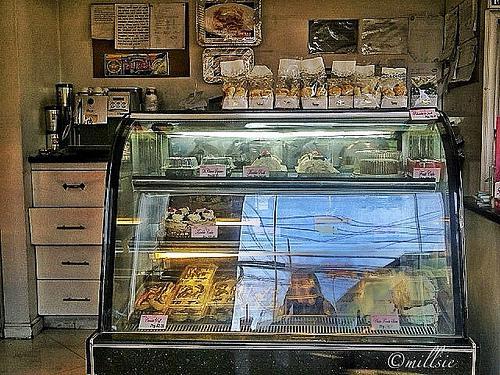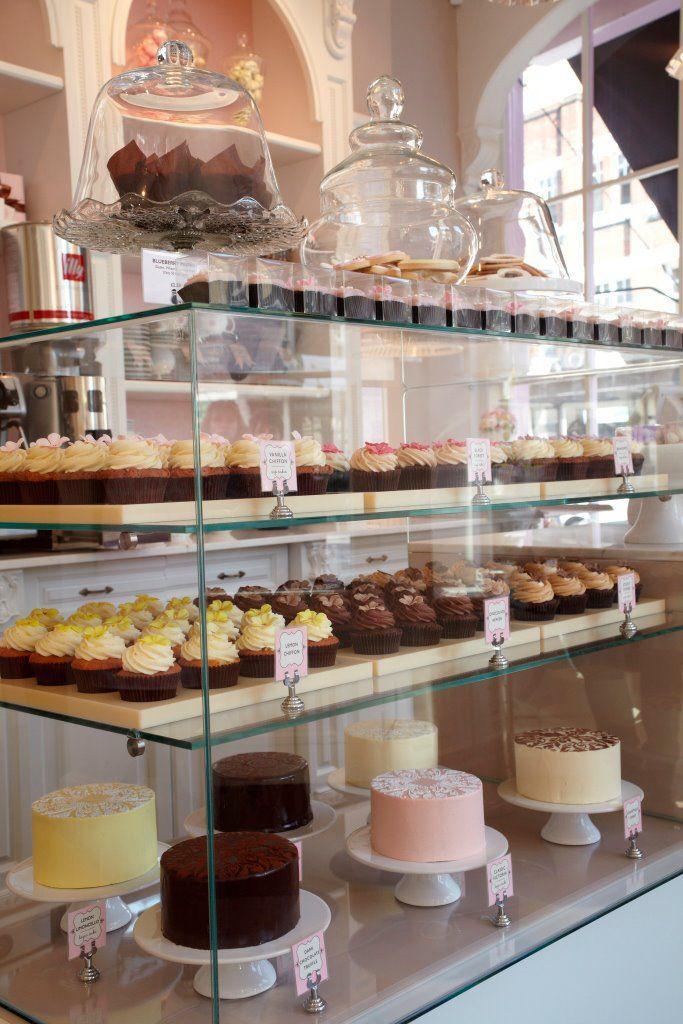The first image is the image on the left, the second image is the image on the right. Evaluate the accuracy of this statement regarding the images: "In one image, dark wall-mounted menu boards have items listed in white writing.". Is it true? Answer yes or no. No. 